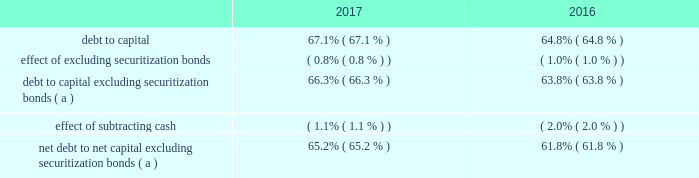Operations may be extended up to four additional years for each unit by mutual agreement of entergy and new york state based on an exigent reliability need for indian point generation .
In accordance with the ferc-approved tariff of the new york independent system operator ( nyiso ) , entergy submitted to the nyiso a notice of generator deactivation based on the dates in the settlement ( no later than april 30 , 2020 for indian point unit 2 and april 30 , 2021 for indian point unit 3 ) .
In december 2017 , nyiso issued a report stating there will not be a system reliability need following the deactivation of indian point .
The nyiso also has advised that it will perform an analysis of the potential competitive impacts of the proposed retirement under provisions of its tariff .
The deadline for the nyiso to make a withholding determination is in dispute and is pending before the ferc .
In addition to contractually agreeing to cease commercial operations early , in february 2017 entergy filed with the nrc an amendment to its license renewal application changing the term of the requested licenses to coincide with the latest possible extension by mutual agreement based on exigent reliability needs : april 30 , 2024 for indian point 2 and april 30 , 2025 for indian point 3 .
If entergy reasonably determines that the nrc will treat the amendment other than as a routine amendment , entergy may withdraw the amendment .
Other provisions of the settlement include termination of all then-existing investigations of indian point by the agencies signing the agreement , which include the new york state department of environmental conservation , the new york state department of state , the new york state department of public service , the new york state department of health , and the new york state attorney general .
The settlement recognizes the right of new york state agencies to pursue new investigations and enforcement actions with respect to new circumstances or existing conditions that become materially exacerbated .
Another provision of the settlement obligates entergy to establish a $ 15 million fund for environmental projects and community support .
Apportionment and allocation of funds to beneficiaries are to be determined by mutual agreement of new york state and entergy .
The settlement recognizes new york state 2019s right to perform an annual inspection of indian point , with scope and timing to be determined by mutual agreement .
In may 2017 a plaintiff filed two parallel state court appeals challenging new york state 2019s actions in signing and implementing the indian point settlement with entergy on the basis that the state failed to perform sufficient environmental analysis of its actions .
All signatories to the settlement agreement , including the entergy affiliates that hold nrc licenses for indian point , were named .
The appeals were voluntarily dismissed in november 2017 .
Entergy corporation and subsidiaries management 2019s financial discussion and analysis liquidity and capital resources this section discusses entergy 2019s capital structure , capital spending plans and other uses of capital , sources of capital , and the cash flow activity presented in the cash flow statement .
Capital structure entergy 2019s capitalization is balanced between equity and debt , as shown in the table .
The increase in the debt to capital ratio for entergy as of december 31 , 2017 is primarily due to an increase in commercial paper outstanding in 2017 as compared to 2016. .
( a ) calculation excludes the arkansas , louisiana , new orleans , and texas securitization bonds , which are non- recourse to entergy arkansas , entergy louisiana , entergy new orleans , and entergy texas , respectively. .
What is the percentage change in the net debt-to-net capital excluding securitization bonds from 2016 to 2017? 
Computations: ((65.2 - 61.8) / 61.8)
Answer: 0.05502. 